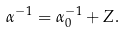Convert formula to latex. <formula><loc_0><loc_0><loc_500><loc_500>\alpha ^ { - 1 } = \alpha _ { 0 } ^ { - 1 } + Z .</formula> 